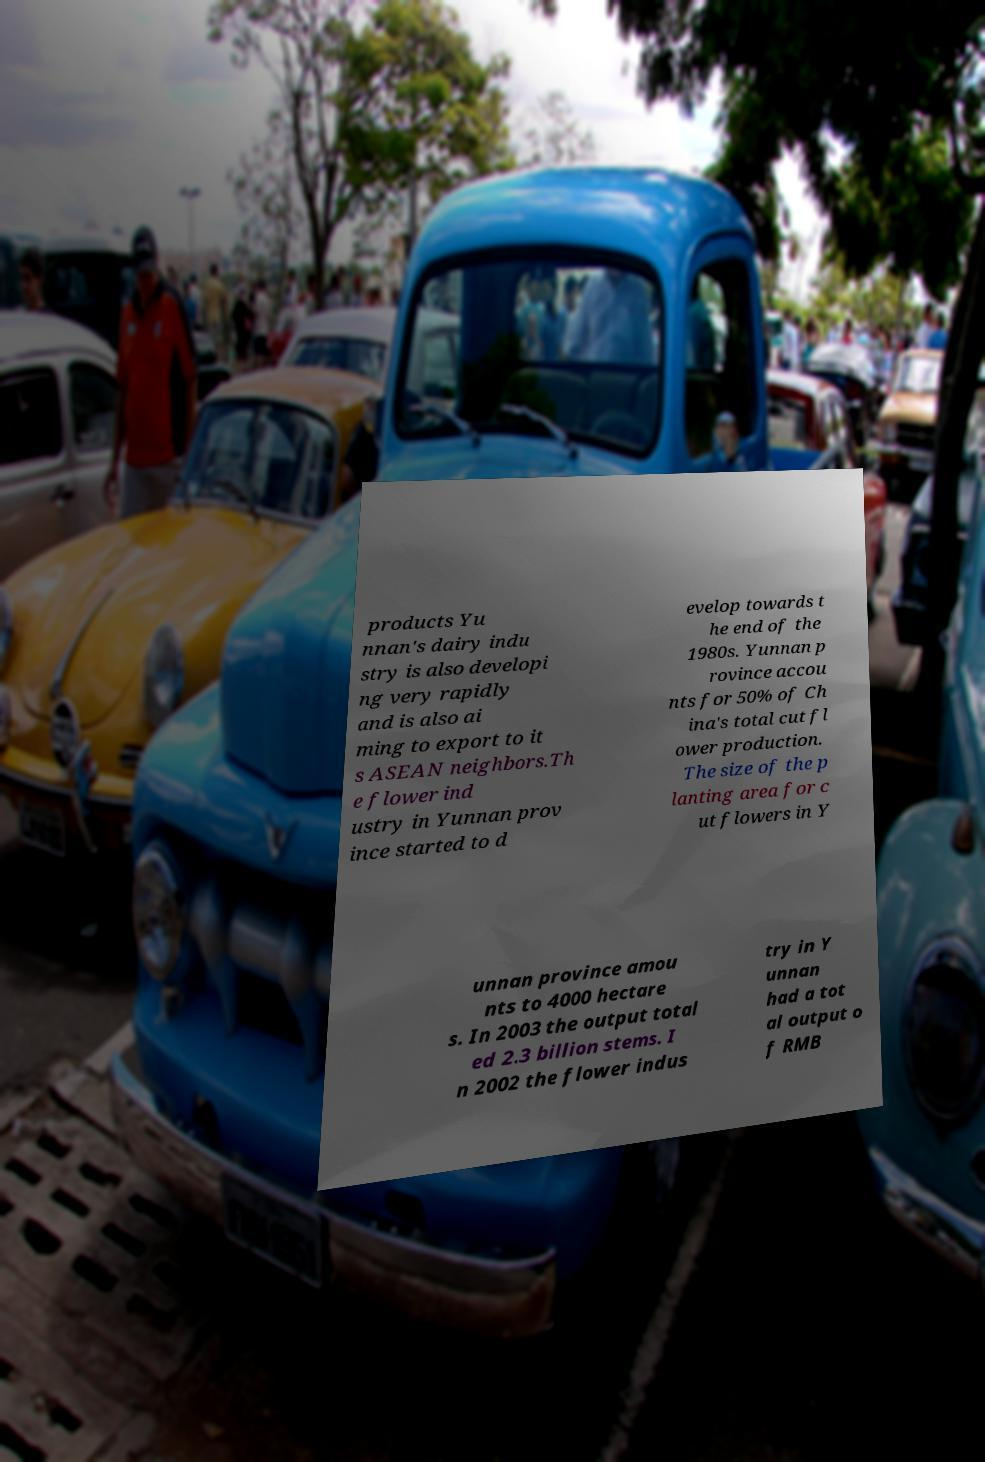For documentation purposes, I need the text within this image transcribed. Could you provide that? products Yu nnan's dairy indu stry is also developi ng very rapidly and is also ai ming to export to it s ASEAN neighbors.Th e flower ind ustry in Yunnan prov ince started to d evelop towards t he end of the 1980s. Yunnan p rovince accou nts for 50% of Ch ina's total cut fl ower production. The size of the p lanting area for c ut flowers in Y unnan province amou nts to 4000 hectare s. In 2003 the output total ed 2.3 billion stems. I n 2002 the flower indus try in Y unnan had a tot al output o f RMB 